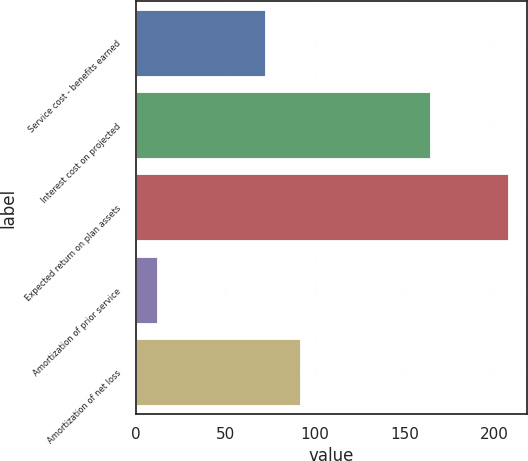Convert chart. <chart><loc_0><loc_0><loc_500><loc_500><bar_chart><fcel>Service cost - benefits earned<fcel>Interest cost on projected<fcel>Expected return on plan assets<fcel>Amortization of prior service<fcel>Amortization of net loss<nl><fcel>72<fcel>164<fcel>208<fcel>12<fcel>91.6<nl></chart> 